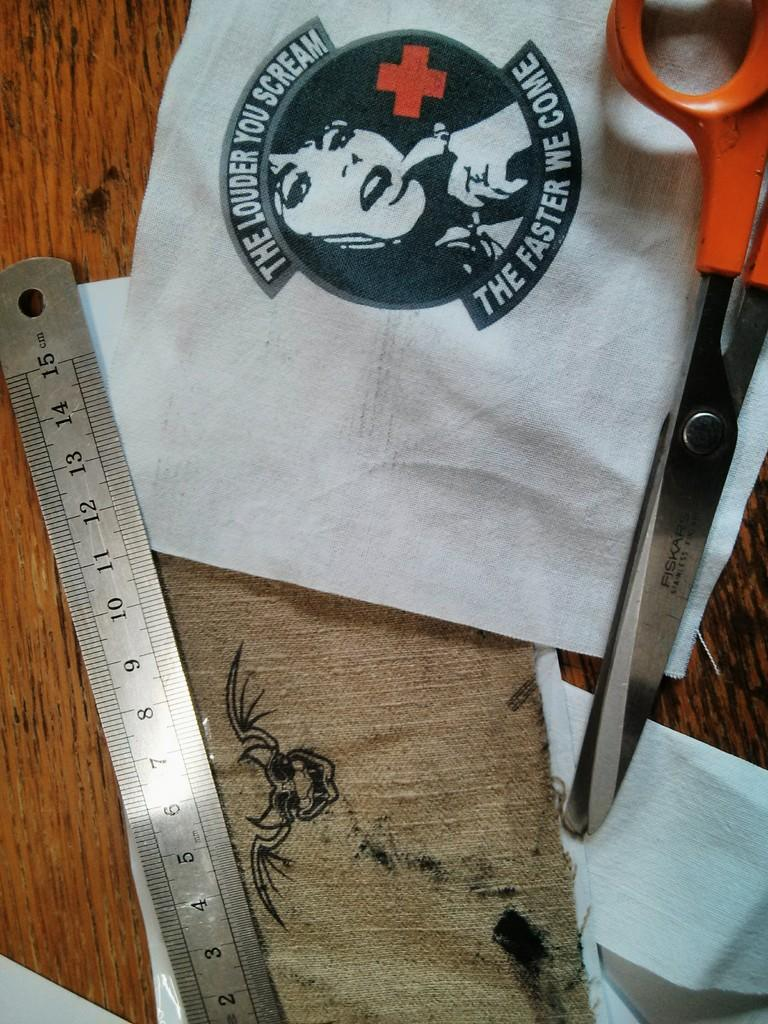<image>
Write a terse but informative summary of the picture. the steel rule,fiskars scissors and white cloth printed the louder you scream the faster we come , are placed in the table 